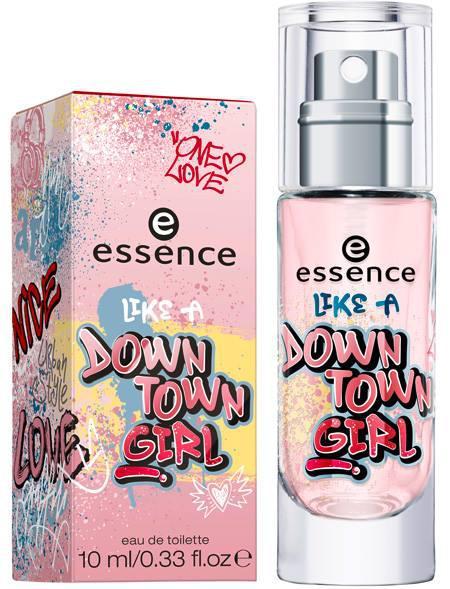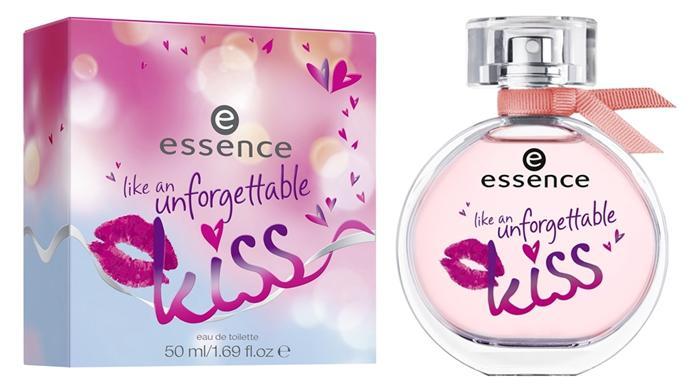The first image is the image on the left, the second image is the image on the right. Examine the images to the left and right. Is the description "one of the perfume bottles has a ribbon on its neck." accurate? Answer yes or no. Yes. 